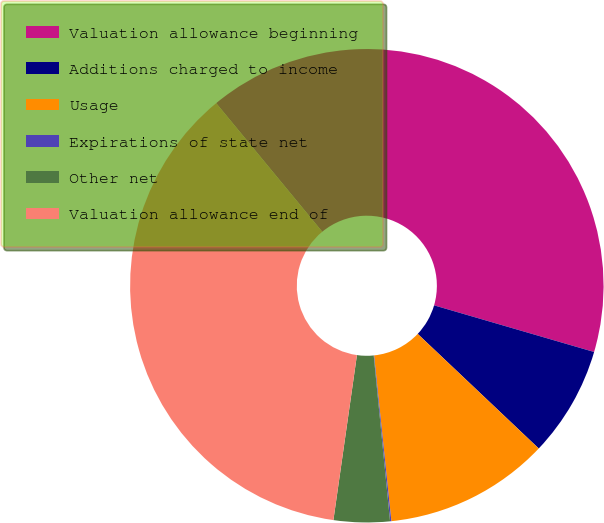Convert chart. <chart><loc_0><loc_0><loc_500><loc_500><pie_chart><fcel>Valuation allowance beginning<fcel>Additions charged to income<fcel>Usage<fcel>Expirations of state net<fcel>Other net<fcel>Valuation allowance end of<nl><fcel>40.49%<fcel>7.55%<fcel>11.28%<fcel>0.09%<fcel>3.82%<fcel>36.76%<nl></chart> 